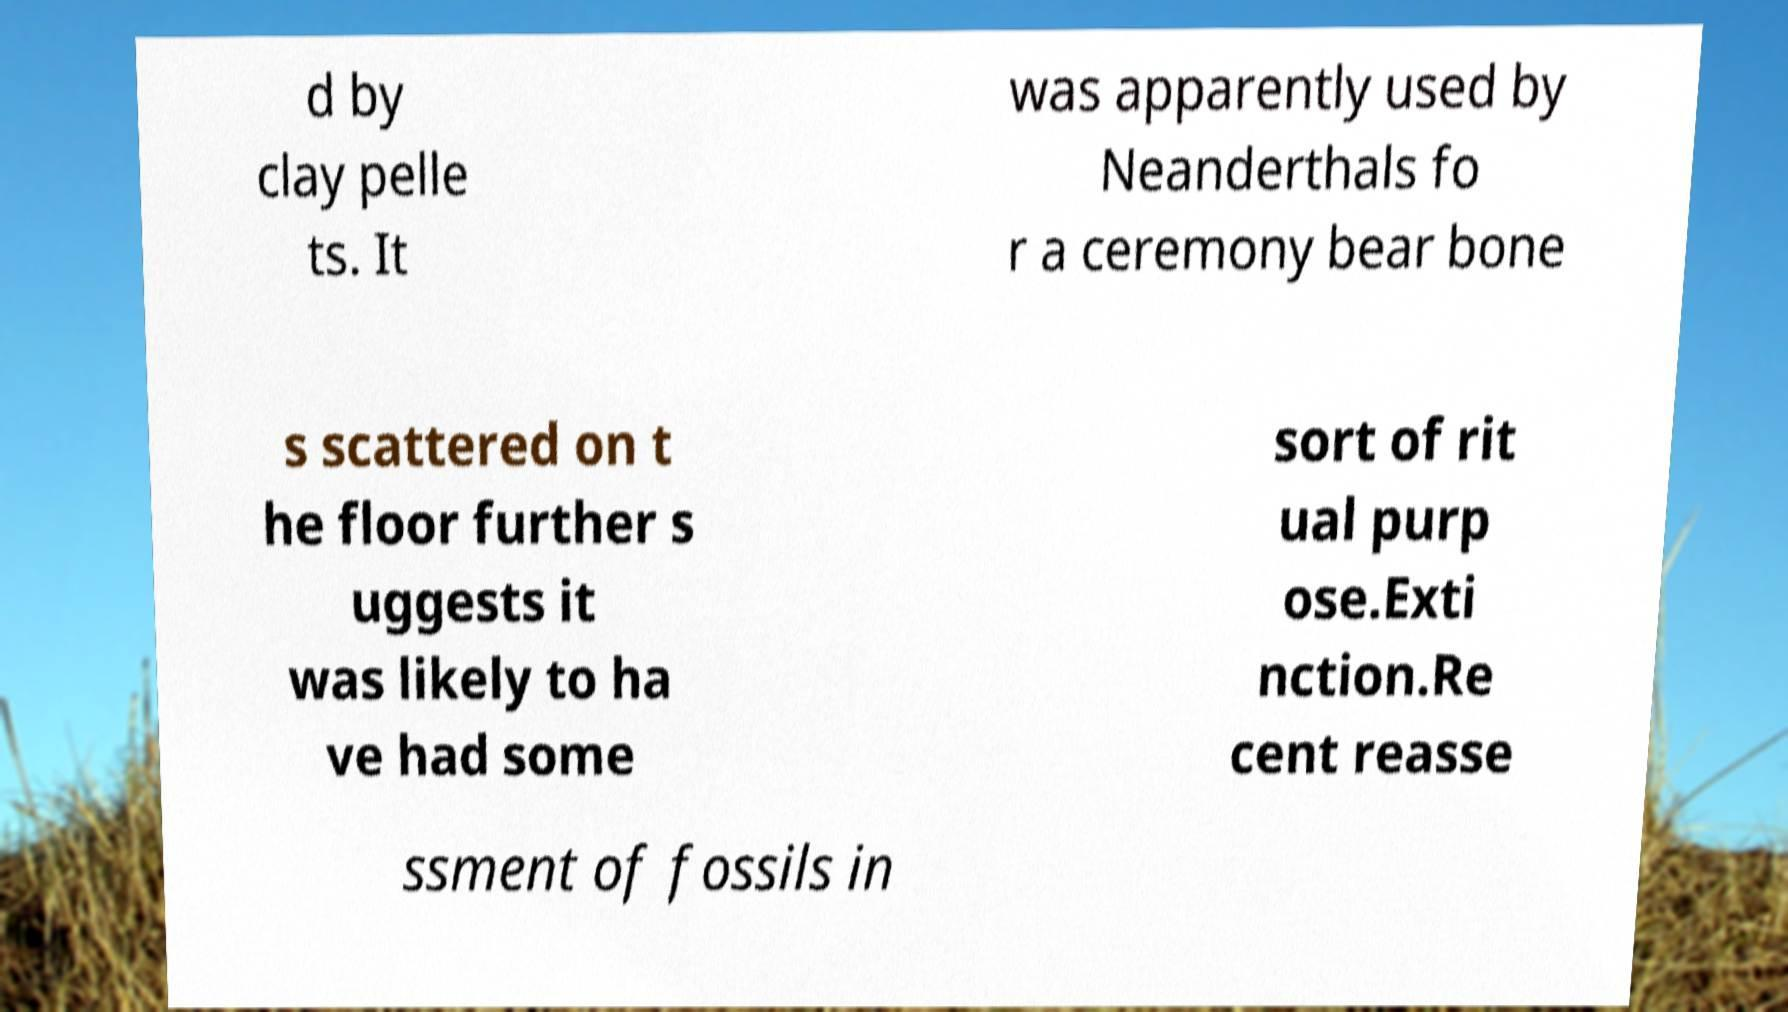There's text embedded in this image that I need extracted. Can you transcribe it verbatim? d by clay pelle ts. It was apparently used by Neanderthals fo r a ceremony bear bone s scattered on t he floor further s uggests it was likely to ha ve had some sort of rit ual purp ose.Exti nction.Re cent reasse ssment of fossils in 